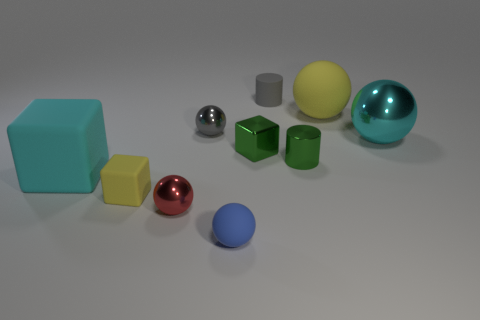Subtract all tiny matte blocks. How many blocks are left? 2 Subtract all cyan balls. How many balls are left? 4 Subtract 1 blocks. How many blocks are left? 2 Subtract all gray blocks. Subtract all yellow cylinders. How many blocks are left? 3 Subtract all big purple matte spheres. Subtract all cyan rubber things. How many objects are left? 9 Add 3 tiny gray shiny objects. How many tiny gray shiny objects are left? 4 Add 3 tiny brown cylinders. How many tiny brown cylinders exist? 3 Subtract 1 blue spheres. How many objects are left? 9 Subtract all cubes. How many objects are left? 7 